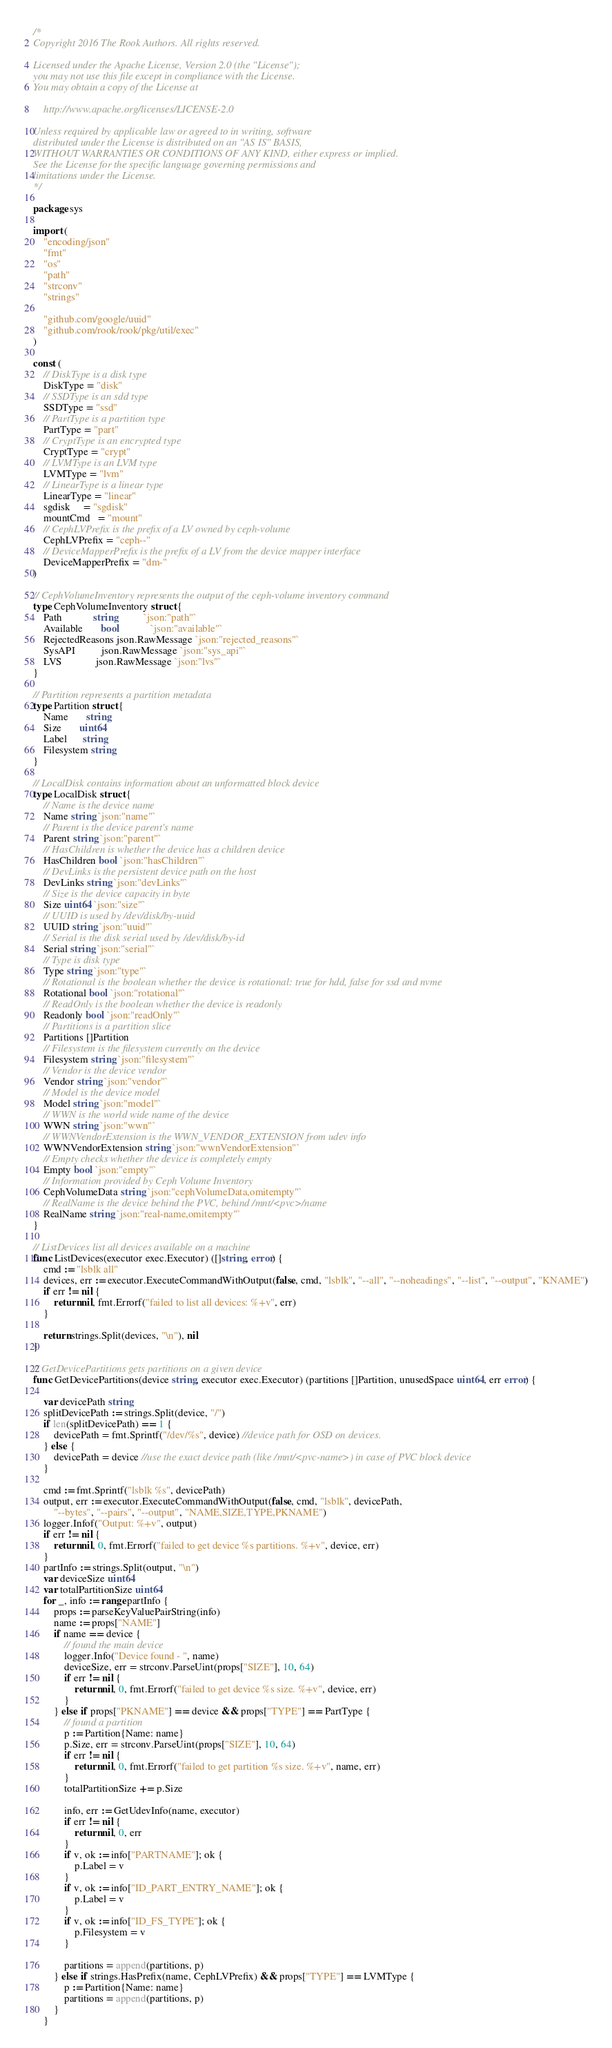<code> <loc_0><loc_0><loc_500><loc_500><_Go_>/*
Copyright 2016 The Rook Authors. All rights reserved.

Licensed under the Apache License, Version 2.0 (the "License");
you may not use this file except in compliance with the License.
You may obtain a copy of the License at

	http://www.apache.org/licenses/LICENSE-2.0

Unless required by applicable law or agreed to in writing, software
distributed under the License is distributed on an "AS IS" BASIS,
WITHOUT WARRANTIES OR CONDITIONS OF ANY KIND, either express or implied.
See the License for the specific language governing permissions and
limitations under the License.
*/

package sys

import (
	"encoding/json"
	"fmt"
	"os"
	"path"
	"strconv"
	"strings"

	"github.com/google/uuid"
	"github.com/rook/rook/pkg/util/exec"
)

const (
	// DiskType is a disk type
	DiskType = "disk"
	// SSDType is an sdd type
	SSDType = "ssd"
	// PartType is a partition type
	PartType = "part"
	// CryptType is an encrypted type
	CryptType = "crypt"
	// LVMType is an LVM type
	LVMType = "lvm"
	// LinearType is a linear type
	LinearType = "linear"
	sgdisk     = "sgdisk"
	mountCmd   = "mount"
	// CephLVPrefix is the prefix of a LV owned by ceph-volume
	CephLVPrefix = "ceph--"
	// DeviceMapperPrefix is the prefix of a LV from the device mapper interface
	DeviceMapperPrefix = "dm-"
)

// CephVolumeInventory represents the output of the ceph-volume inventory command
type CephVolumeInventory struct {
	Path            string          `json:"path"`
	Available       bool            `json:"available"`
	RejectedReasons json.RawMessage `json:"rejected_reasons"`
	SysAPI          json.RawMessage `json:"sys_api"`
	LVS             json.RawMessage `json:"lvs"`
}

// Partition represents a partition metadata
type Partition struct {
	Name       string
	Size       uint64
	Label      string
	Filesystem string
}

// LocalDisk contains information about an unformatted block device
type LocalDisk struct {
	// Name is the device name
	Name string `json:"name"`
	// Parent is the device parent's name
	Parent string `json:"parent"`
	// HasChildren is whether the device has a children device
	HasChildren bool `json:"hasChildren"`
	// DevLinks is the persistent device path on the host
	DevLinks string `json:"devLinks"`
	// Size is the device capacity in byte
	Size uint64 `json:"size"`
	// UUID is used by /dev/disk/by-uuid
	UUID string `json:"uuid"`
	// Serial is the disk serial used by /dev/disk/by-id
	Serial string `json:"serial"`
	// Type is disk type
	Type string `json:"type"`
	// Rotational is the boolean whether the device is rotational: true for hdd, false for ssd and nvme
	Rotational bool `json:"rotational"`
	// ReadOnly is the boolean whether the device is readonly
	Readonly bool `json:"readOnly"`
	// Partitions is a partition slice
	Partitions []Partition
	// Filesystem is the filesystem currently on the device
	Filesystem string `json:"filesystem"`
	// Vendor is the device vendor
	Vendor string `json:"vendor"`
	// Model is the device model
	Model string `json:"model"`
	// WWN is the world wide name of the device
	WWN string `json:"wwn"`
	// WWNVendorExtension is the WWN_VENDOR_EXTENSION from udev info
	WWNVendorExtension string `json:"wwnVendorExtension"`
	// Empty checks whether the device is completely empty
	Empty bool `json:"empty"`
	// Information provided by Ceph Volume Inventory
	CephVolumeData string `json:"cephVolumeData,omitempty"`
	// RealName is the device behind the PVC, behind /mnt/<pvc>/name
	RealName string `json:"real-name,omitempty"`
}

// ListDevices list all devices available on a machine
func ListDevices(executor exec.Executor) ([]string, error) {
	cmd := "lsblk all"
	devices, err := executor.ExecuteCommandWithOutput(false, cmd, "lsblk", "--all", "--noheadings", "--list", "--output", "KNAME")
	if err != nil {
		return nil, fmt.Errorf("failed to list all devices: %+v", err)
	}

	return strings.Split(devices, "\n"), nil
}

// GetDevicePartitions gets partitions on a given device
func GetDevicePartitions(device string, executor exec.Executor) (partitions []Partition, unusedSpace uint64, err error) {

	var devicePath string
	splitDevicePath := strings.Split(device, "/")
	if len(splitDevicePath) == 1 {
		devicePath = fmt.Sprintf("/dev/%s", device) //device path for OSD on devices.
	} else {
		devicePath = device //use the exact device path (like /mnt/<pvc-name>) in case of PVC block device
	}

	cmd := fmt.Sprintf("lsblk %s", devicePath)
	output, err := executor.ExecuteCommandWithOutput(false, cmd, "lsblk", devicePath,
		"--bytes", "--pairs", "--output", "NAME,SIZE,TYPE,PKNAME")
	logger.Infof("Output: %+v", output)
	if err != nil {
		return nil, 0, fmt.Errorf("failed to get device %s partitions. %+v", device, err)
	}
	partInfo := strings.Split(output, "\n")
	var deviceSize uint64
	var totalPartitionSize uint64
	for _, info := range partInfo {
		props := parseKeyValuePairString(info)
		name := props["NAME"]
		if name == device {
			// found the main device
			logger.Info("Device found - ", name)
			deviceSize, err = strconv.ParseUint(props["SIZE"], 10, 64)
			if err != nil {
				return nil, 0, fmt.Errorf("failed to get device %s size. %+v", device, err)
			}
		} else if props["PKNAME"] == device && props["TYPE"] == PartType {
			// found a partition
			p := Partition{Name: name}
			p.Size, err = strconv.ParseUint(props["SIZE"], 10, 64)
			if err != nil {
				return nil, 0, fmt.Errorf("failed to get partition %s size. %+v", name, err)
			}
			totalPartitionSize += p.Size

			info, err := GetUdevInfo(name, executor)
			if err != nil {
				return nil, 0, err
			}
			if v, ok := info["PARTNAME"]; ok {
				p.Label = v
			}
			if v, ok := info["ID_PART_ENTRY_NAME"]; ok {
				p.Label = v
			}
			if v, ok := info["ID_FS_TYPE"]; ok {
				p.Filesystem = v
			}

			partitions = append(partitions, p)
		} else if strings.HasPrefix(name, CephLVPrefix) && props["TYPE"] == LVMType {
			p := Partition{Name: name}
			partitions = append(partitions, p)
		}
	}
</code> 